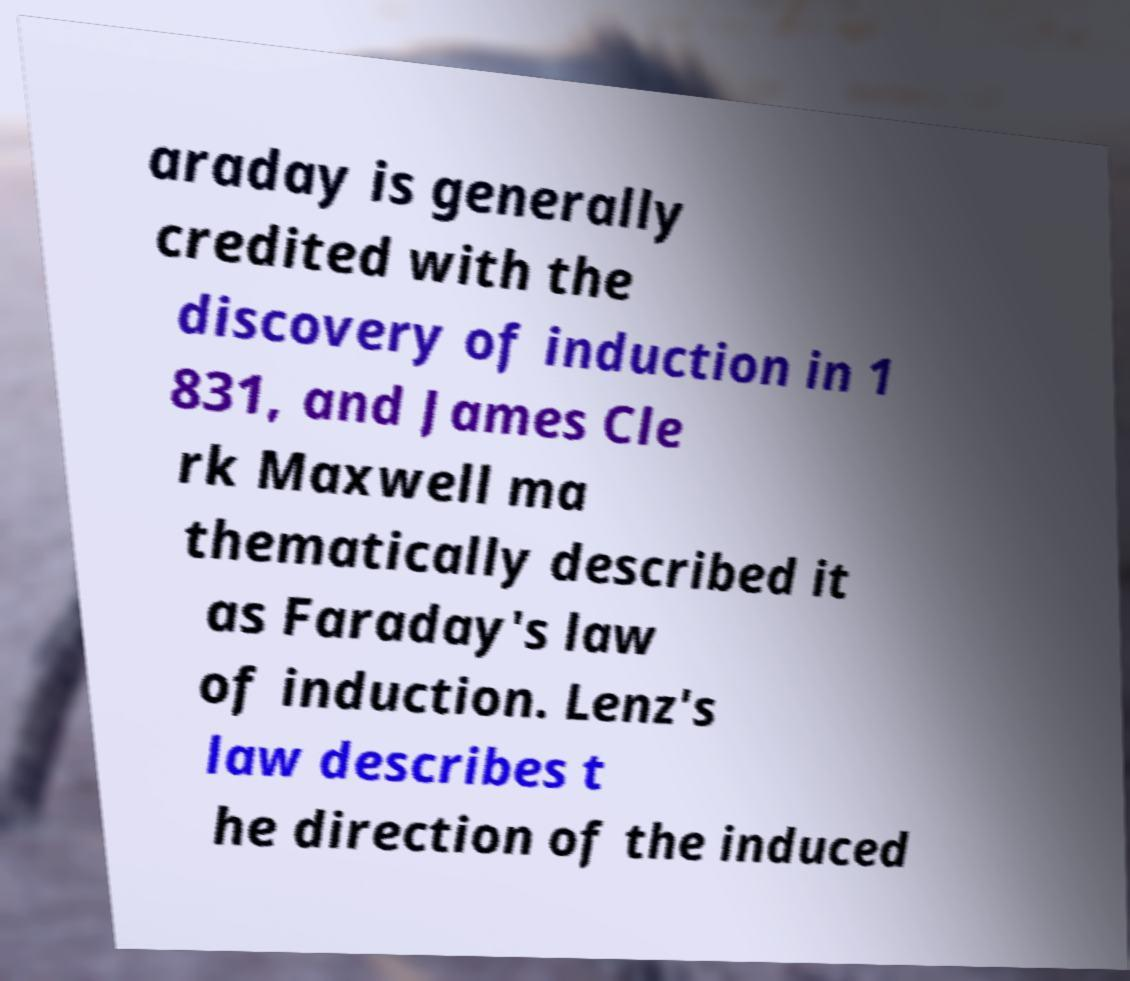Can you accurately transcribe the text from the provided image for me? araday is generally credited with the discovery of induction in 1 831, and James Cle rk Maxwell ma thematically described it as Faraday's law of induction. Lenz's law describes t he direction of the induced 